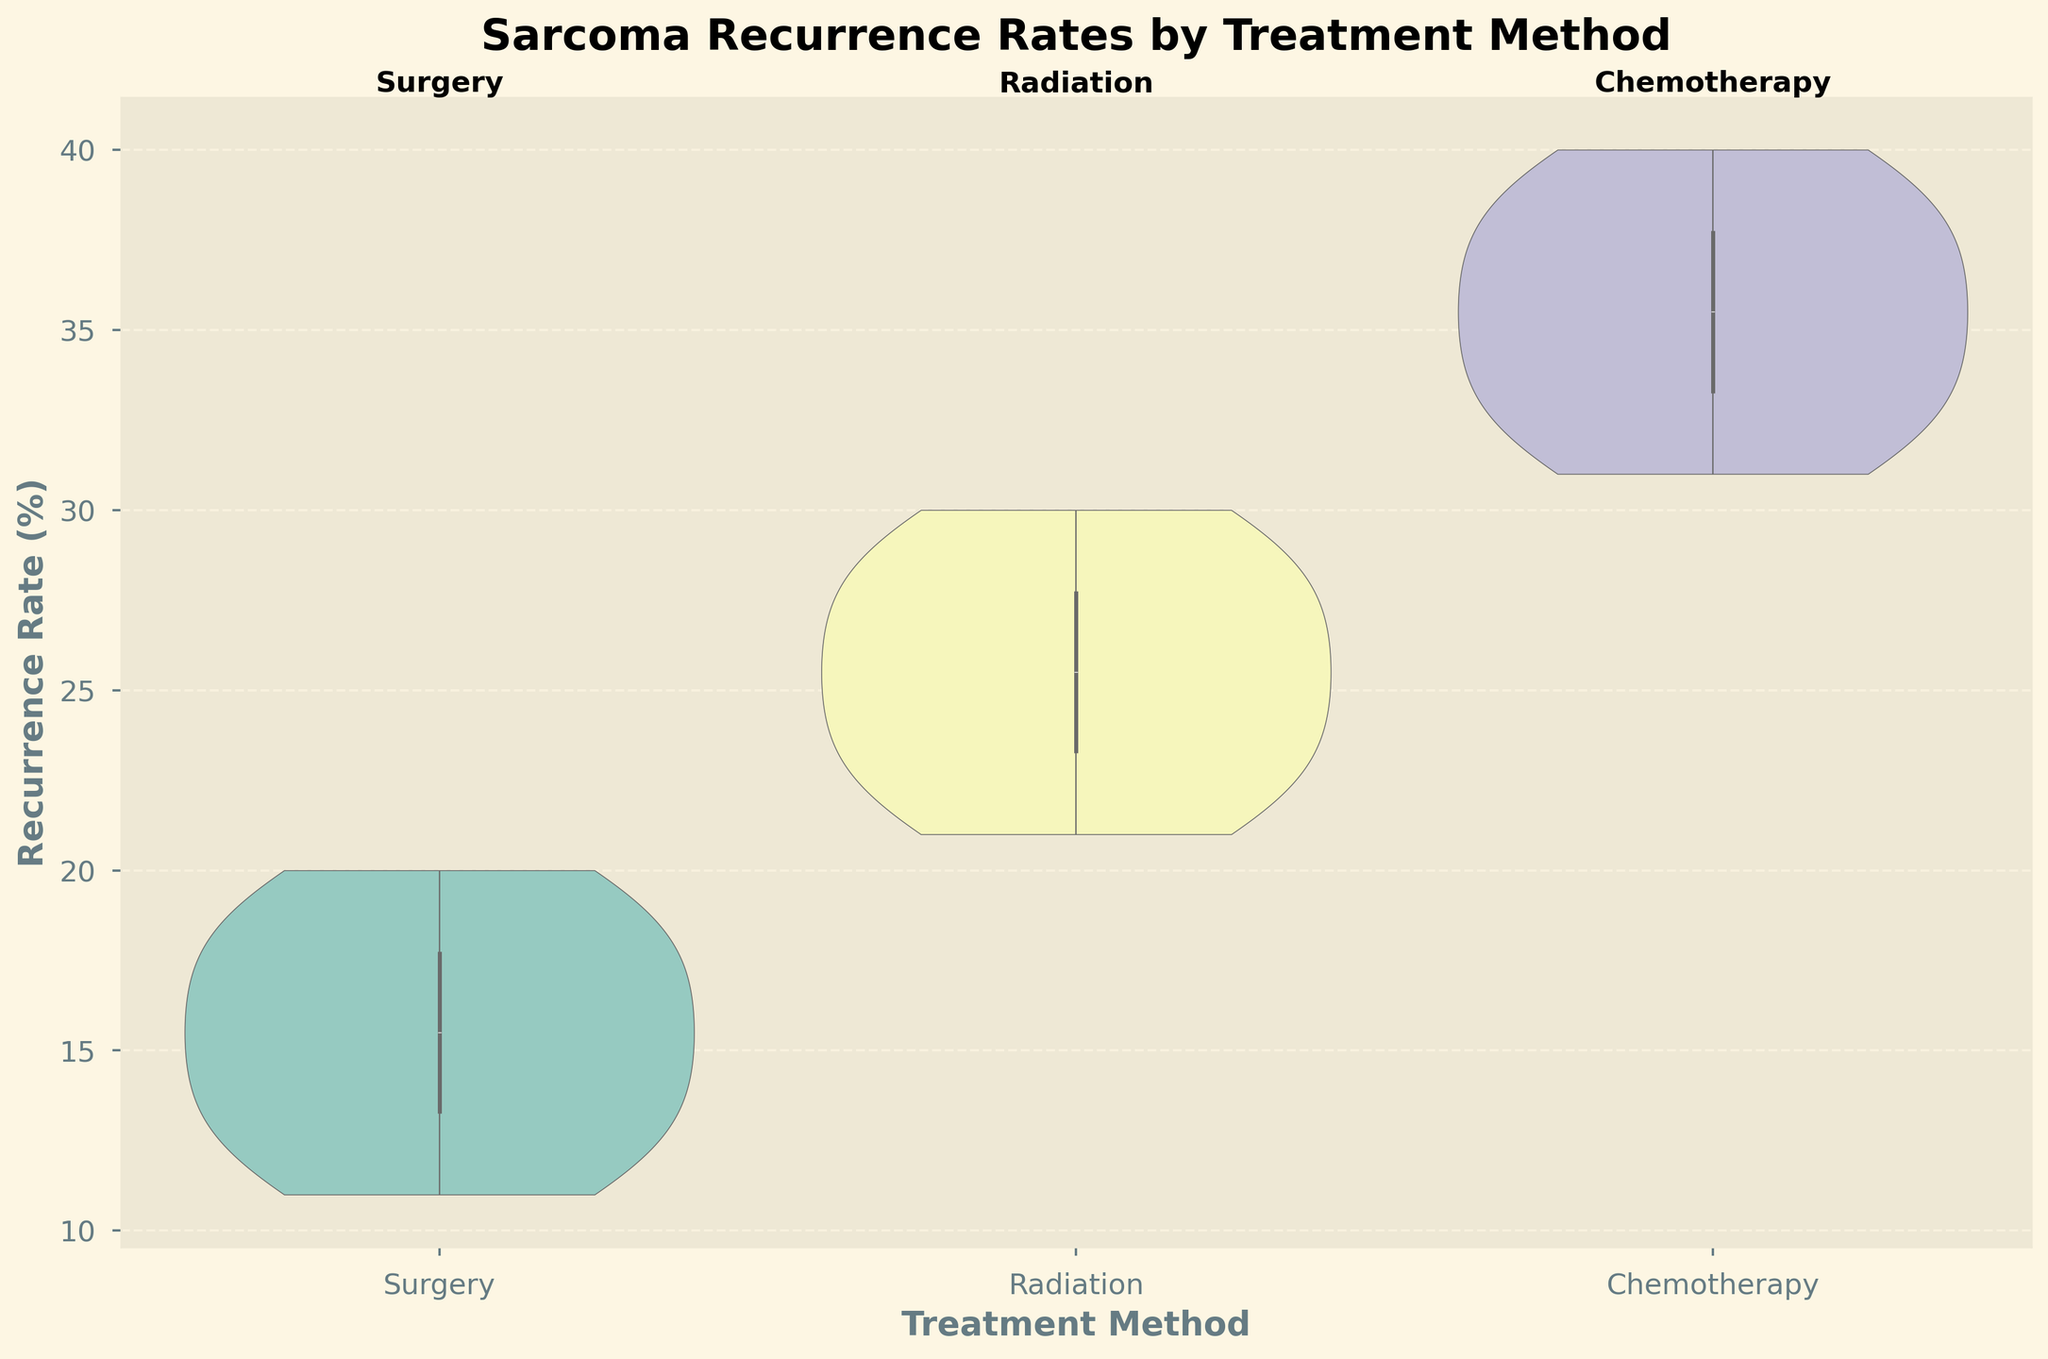What treatment method has the highest recurrence rate overall? By examining the height and density of the violin chart, it's clear that "Chemotherapy" has the highest recurrence rate overall, with values reaching up to 40%.
Answer: Chemotherapy What is the title of the figure? The title is stated at the top of the figure in bold font.
Answer: Sarcoma Recurrence Rates by Treatment Method How many data points are there for each treatment method? Counting the individual points within each violin plot: Surgery has 10 points, Radiation has 10 points, and Chemotherapy has 10 points.
Answer: 10 Which treatment method shows the lowest recurrence rate? By looking at the bottom values of the violin charts, "Surgery" has the lowest recurrence rate, going down to 11%.
Answer: Surgery What are the median recurrence rates for each treatment method? The median can be inferred from the thick line in the middle of the violin plot: Surgery's median is around 15-16%, Radiation's median is around 25-26%, and Chemotherapy's median is around 36-37%.
Answer: Surgery: 15-16%, Radiation: 25-26%, Chemotherapy: 36-37% Which treatment method has the most variability in recurrence rates? Variability can be observed by the width of the violin plots. "Chemotherapy" has the widest plot, indicating more variability.
Answer: Chemotherapy What recurrence rate values cover the interquartile range (IQR) for Radiation? The IQR is the range between the first and third quartiles, which is shown by the box within the violin plot: For Radiation, this is between approximately 23% and 27%.
Answer: 23%-27% How does the peak density of recurrence rates compare between Surgery and Radiation? The peak density is indicated by the widest section of the violin plot: Surgery's peak is around 14-16%, while Radiation's peak is around 25-27%.
Answer: Surgery: 14-16%, Radiation: 25-27% What is the average recurrence rate for Chemotherapy? Summing up the recurrence rates for Chemotherapy and dividing by the number of points: (35+32+34+33+37+31+36+38+40+39) / 10 = 345 / 10 = 34.5%
Answer: 34.5% Is there any overlap in recurrence rate values between Surgery and Radiation? By examining the violin plots, both Surgery and Radiation overlap within the recurrence rates of approximately 21%-19%.
Answer: Yes 